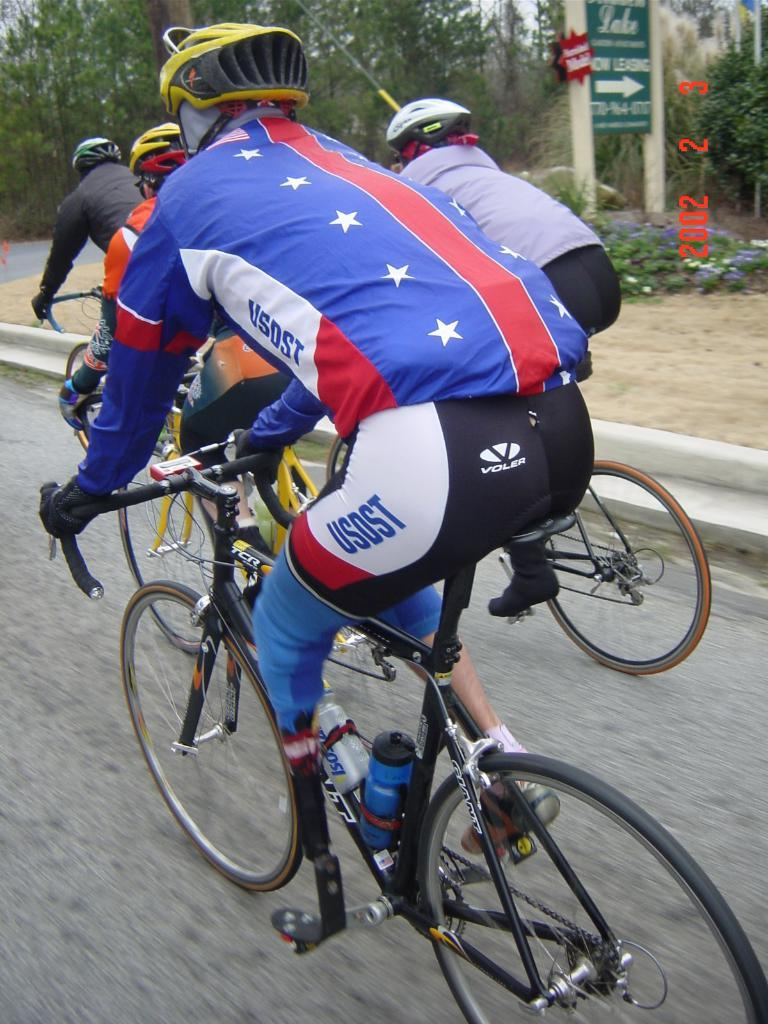What are the people in the image doing? The people in the image are riding bicycles. What can be seen in the background of the image? There are trees in the background of the image. What is the board visible in the image used for? The purpose of the board in the image is not clear from the provided facts. What type of surface are the bicycles riding on? There is a road at the bottom of the image, which suggests that the bicycles are riding on a road. What type of hand can be seen holding a ball in the image? There is no hand or ball present in the image; it features people riding bicycles. 